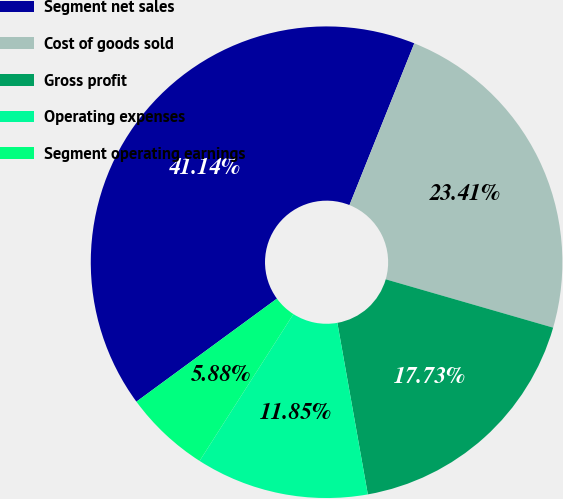Convert chart. <chart><loc_0><loc_0><loc_500><loc_500><pie_chart><fcel>Segment net sales<fcel>Cost of goods sold<fcel>Gross profit<fcel>Operating expenses<fcel>Segment operating earnings<nl><fcel>41.14%<fcel>23.41%<fcel>17.73%<fcel>11.85%<fcel>5.88%<nl></chart> 